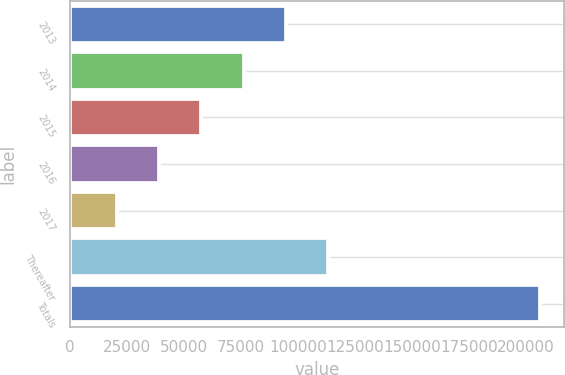<chart> <loc_0><loc_0><loc_500><loc_500><bar_chart><fcel>2013<fcel>2014<fcel>2015<fcel>2016<fcel>2017<fcel>Thereafter<fcel>Totals<nl><fcel>94810.2<fcel>76226.4<fcel>57642.6<fcel>39058.8<fcel>20475<fcel>113394<fcel>206313<nl></chart> 